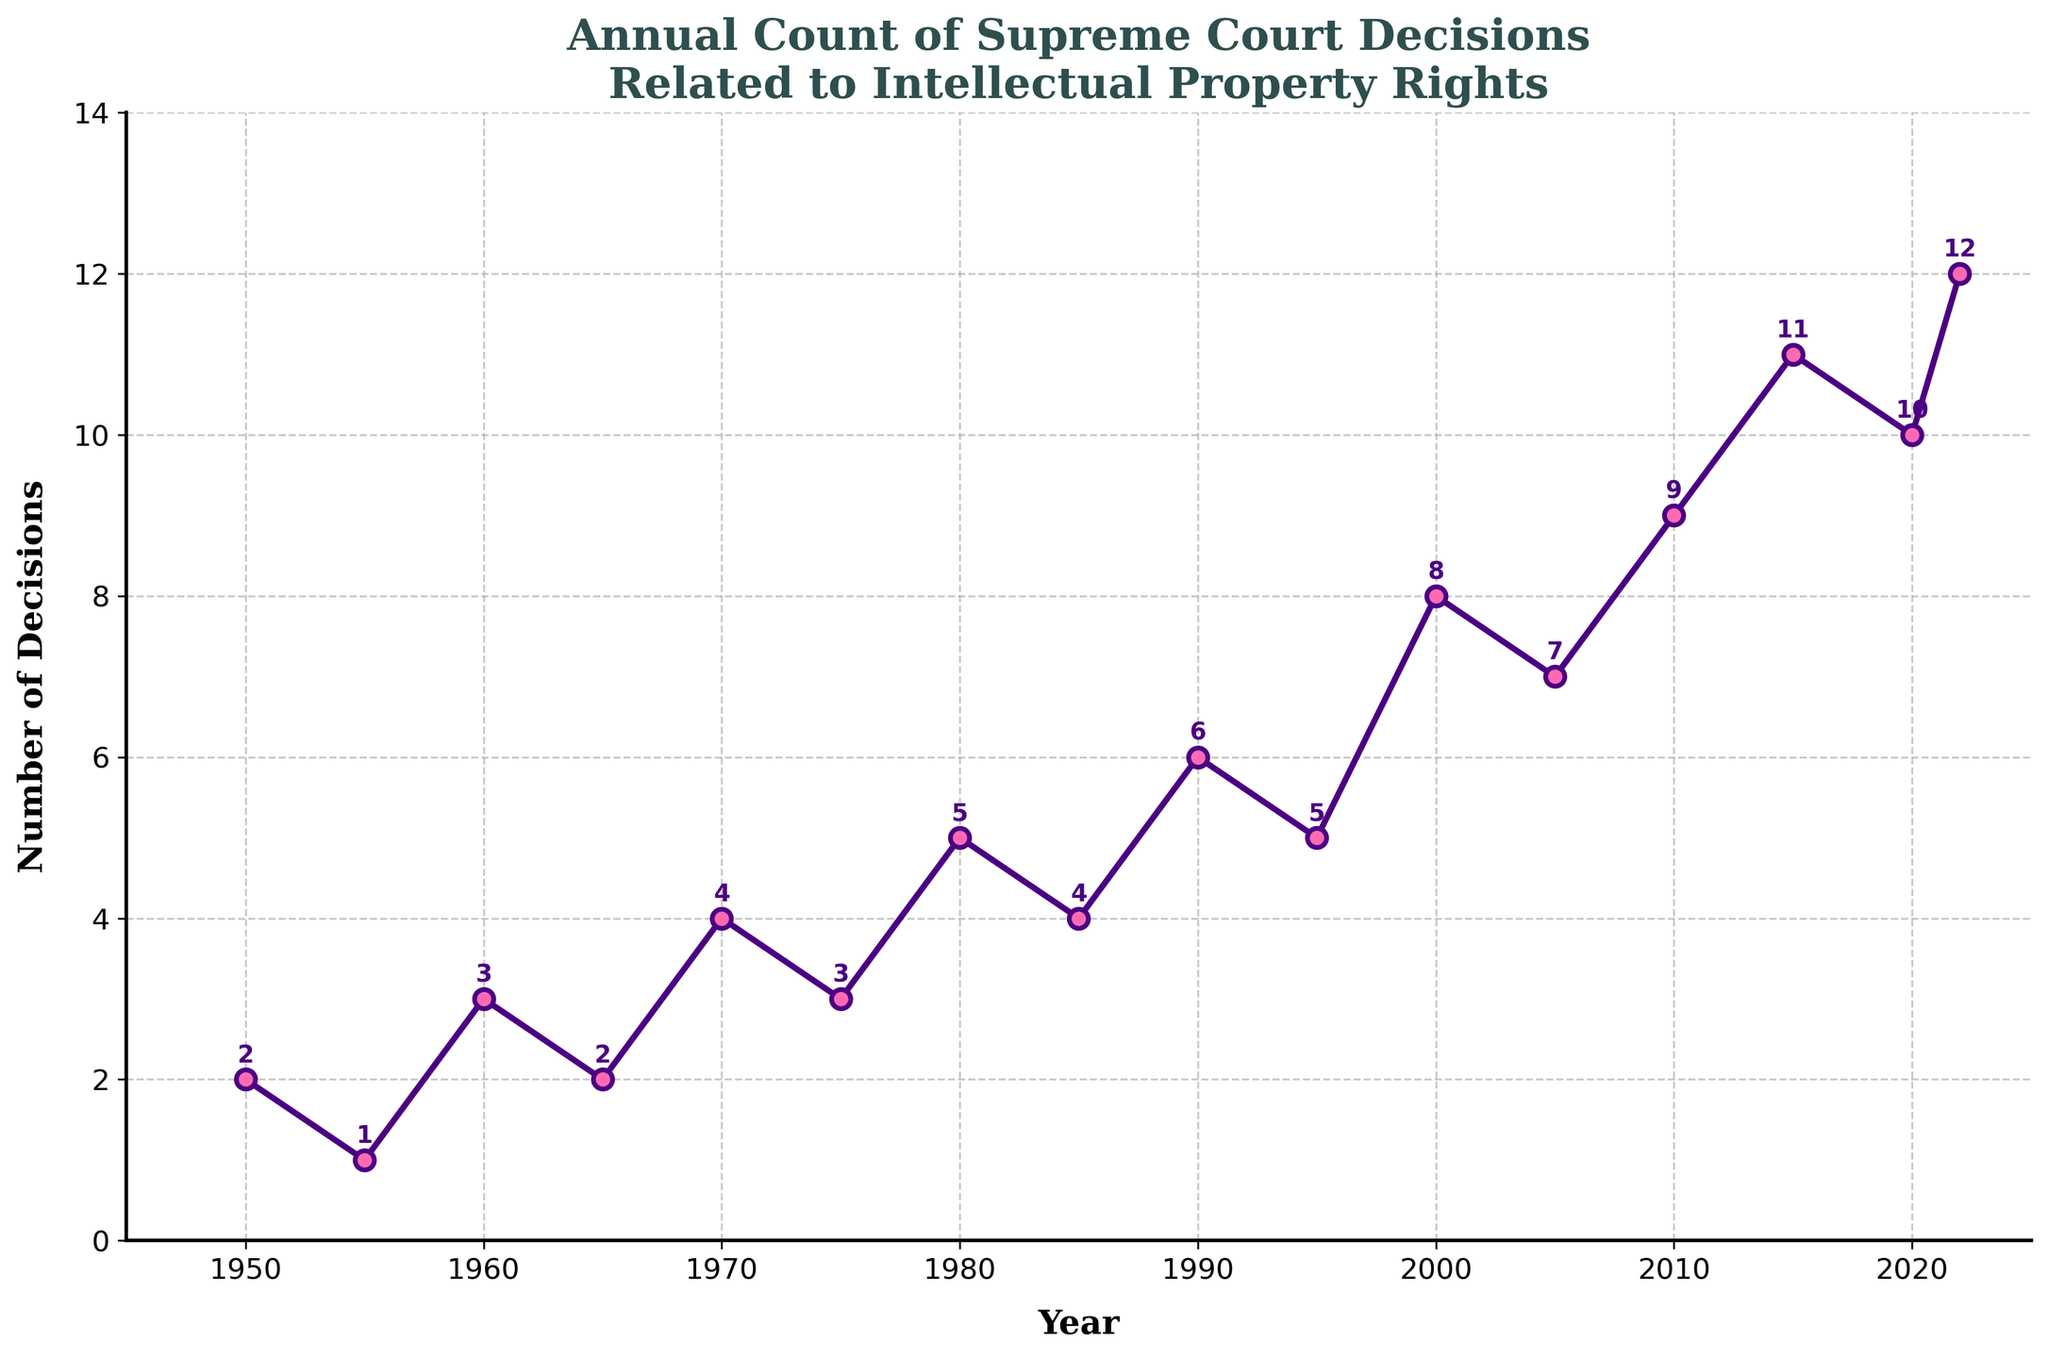What is the highest number of Supreme Court IP decisions in a single year? To find the highest number of decisions, look at the plot and identify the year with the peak value on the y-axis. The peak value is associated with the year 2022, which has 12 decisions as annotated on the plot.
Answer: 12 In which year did the Supreme Court decide on 10 IP cases? Identify the point on the plot where the y-axis value is 10 and refer to the x-axis for the corresponding year. The annotated value indicates that there were 10 decisions in the year 2020.
Answer: 2020 How does the count of decisions in 2015 compare to the count in 1980? Locate the values for the years 2015 and 1980 on the plot and compare them. The count is 11 for 2015 and 5 for 1980, so 2015 has a higher count.
Answer: 2015 has more decisions What is the sum of the number of decisions in 1970 and 1990? Identify the values for 1970 and 1990 from the plot (4 and 6 respectively), then add them together. 4 + 6 = 10.
Answer: 10 What is the average number of decisions per decade from 1980 to 2020? Sum the counts for the years 1980 (5), 1990 (6), 2000 (8), 2010 (9), and 2020 (10). Then, divide by the number of decades: (5 + 6 + 8 + 9 + 10) / 5 = 38 / 5 = 7.6.
Answer: 7.6 Between which years did the number of Supreme Court IP decisions increase the most? Observe the plot for the steepest increase. From 2010 (9 decisions) to 2015 (11 decisions), a 2-decision increase happens. However, from 2000 (8 decisions) to 2005 (7 decisions), there is actually a decrease. The most prominent increase is from 2015 (11 decisions) to 2022 (12 decisions), with a 1 increase is the actual steepest. Comparing all gaps between data points, the period from 2010 to 2015 has sharpest increase of 2.
Answer: 2010 to 2015 What visual attributes differentiate the markers on the line plot? Identify characteristics of the markers on the plot. The markers are circles ('o'), filled with pink, and have a purple border.
Answer: Pink with a purple border 